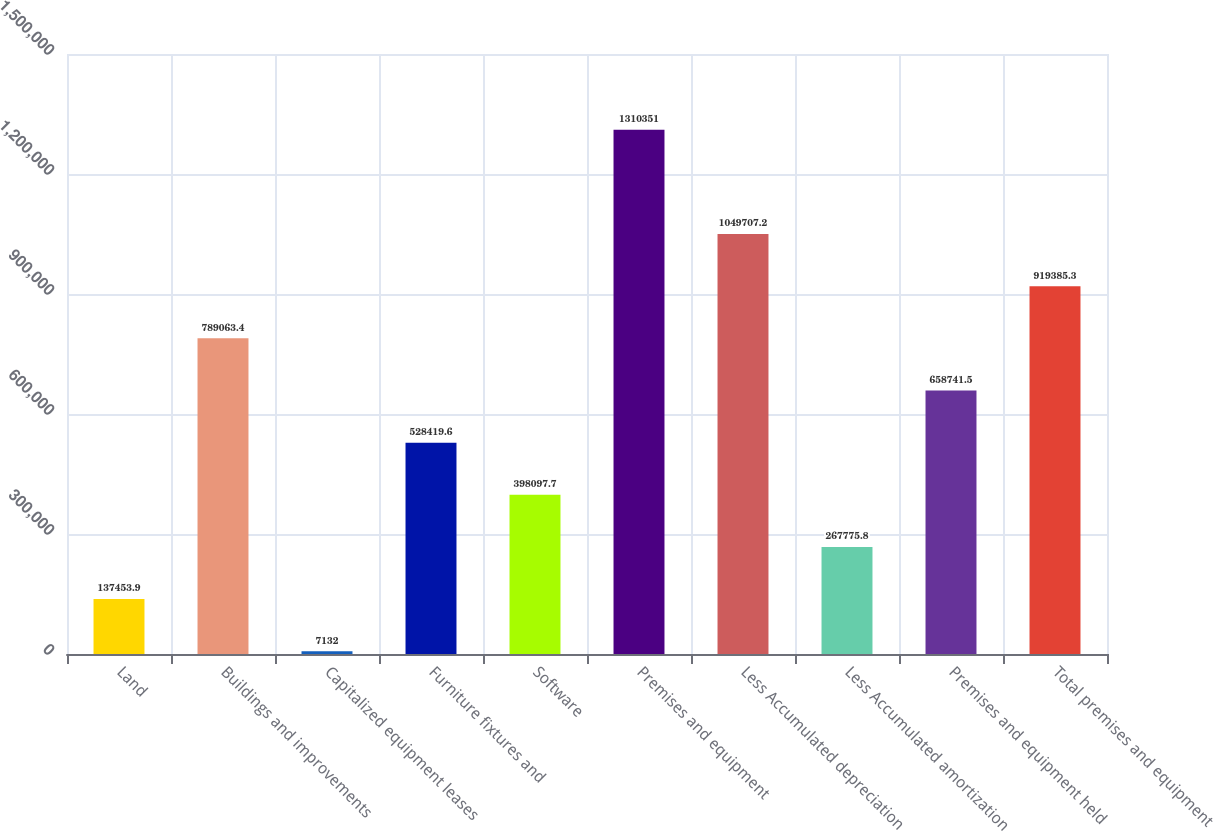Convert chart. <chart><loc_0><loc_0><loc_500><loc_500><bar_chart><fcel>Land<fcel>Buildings and improvements<fcel>Capitalized equipment leases<fcel>Furniture fixtures and<fcel>Software<fcel>Premises and equipment<fcel>Less Accumulated depreciation<fcel>Less Accumulated amortization<fcel>Premises and equipment held<fcel>Total premises and equipment<nl><fcel>137454<fcel>789063<fcel>7132<fcel>528420<fcel>398098<fcel>1.31035e+06<fcel>1.04971e+06<fcel>267776<fcel>658742<fcel>919385<nl></chart> 